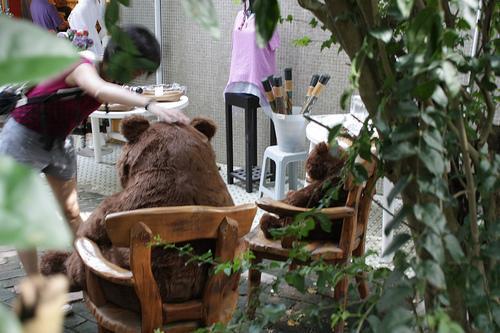How many stuffed animal bears are in the picture?
Give a very brief answer. 2. 